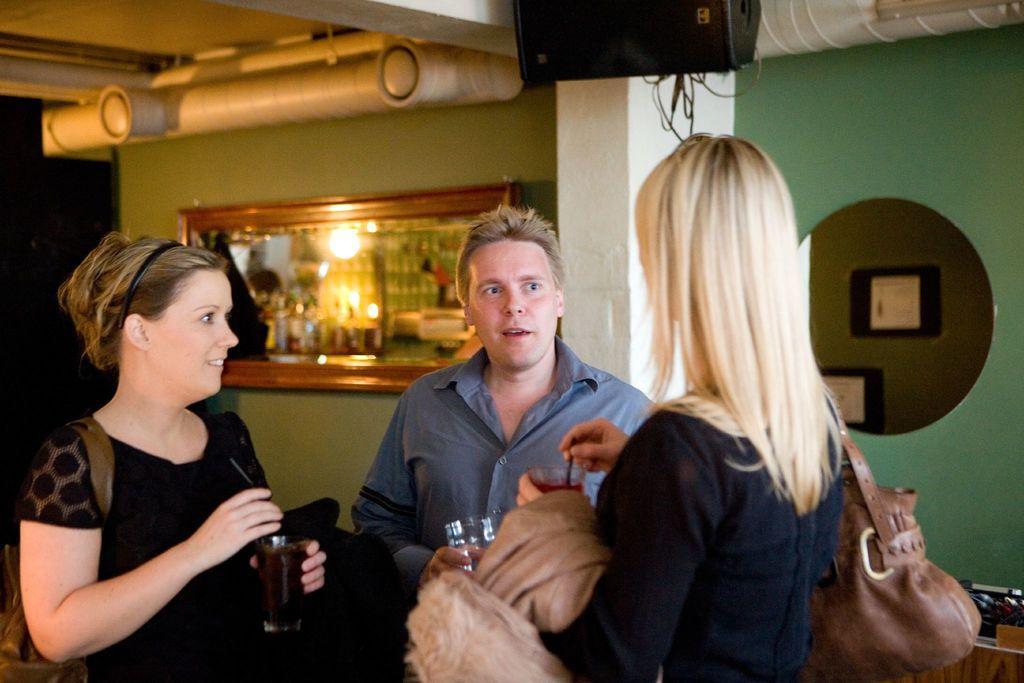In one or two sentences, can you explain what this image depicts? In this image I can see three people with different color dresses and these people are holding the glasses. In the background I can see the mirror and the board to the wall and I can see the reflection of few lights and objects in the mirror. I can see the pipes and the speaker at the top. 